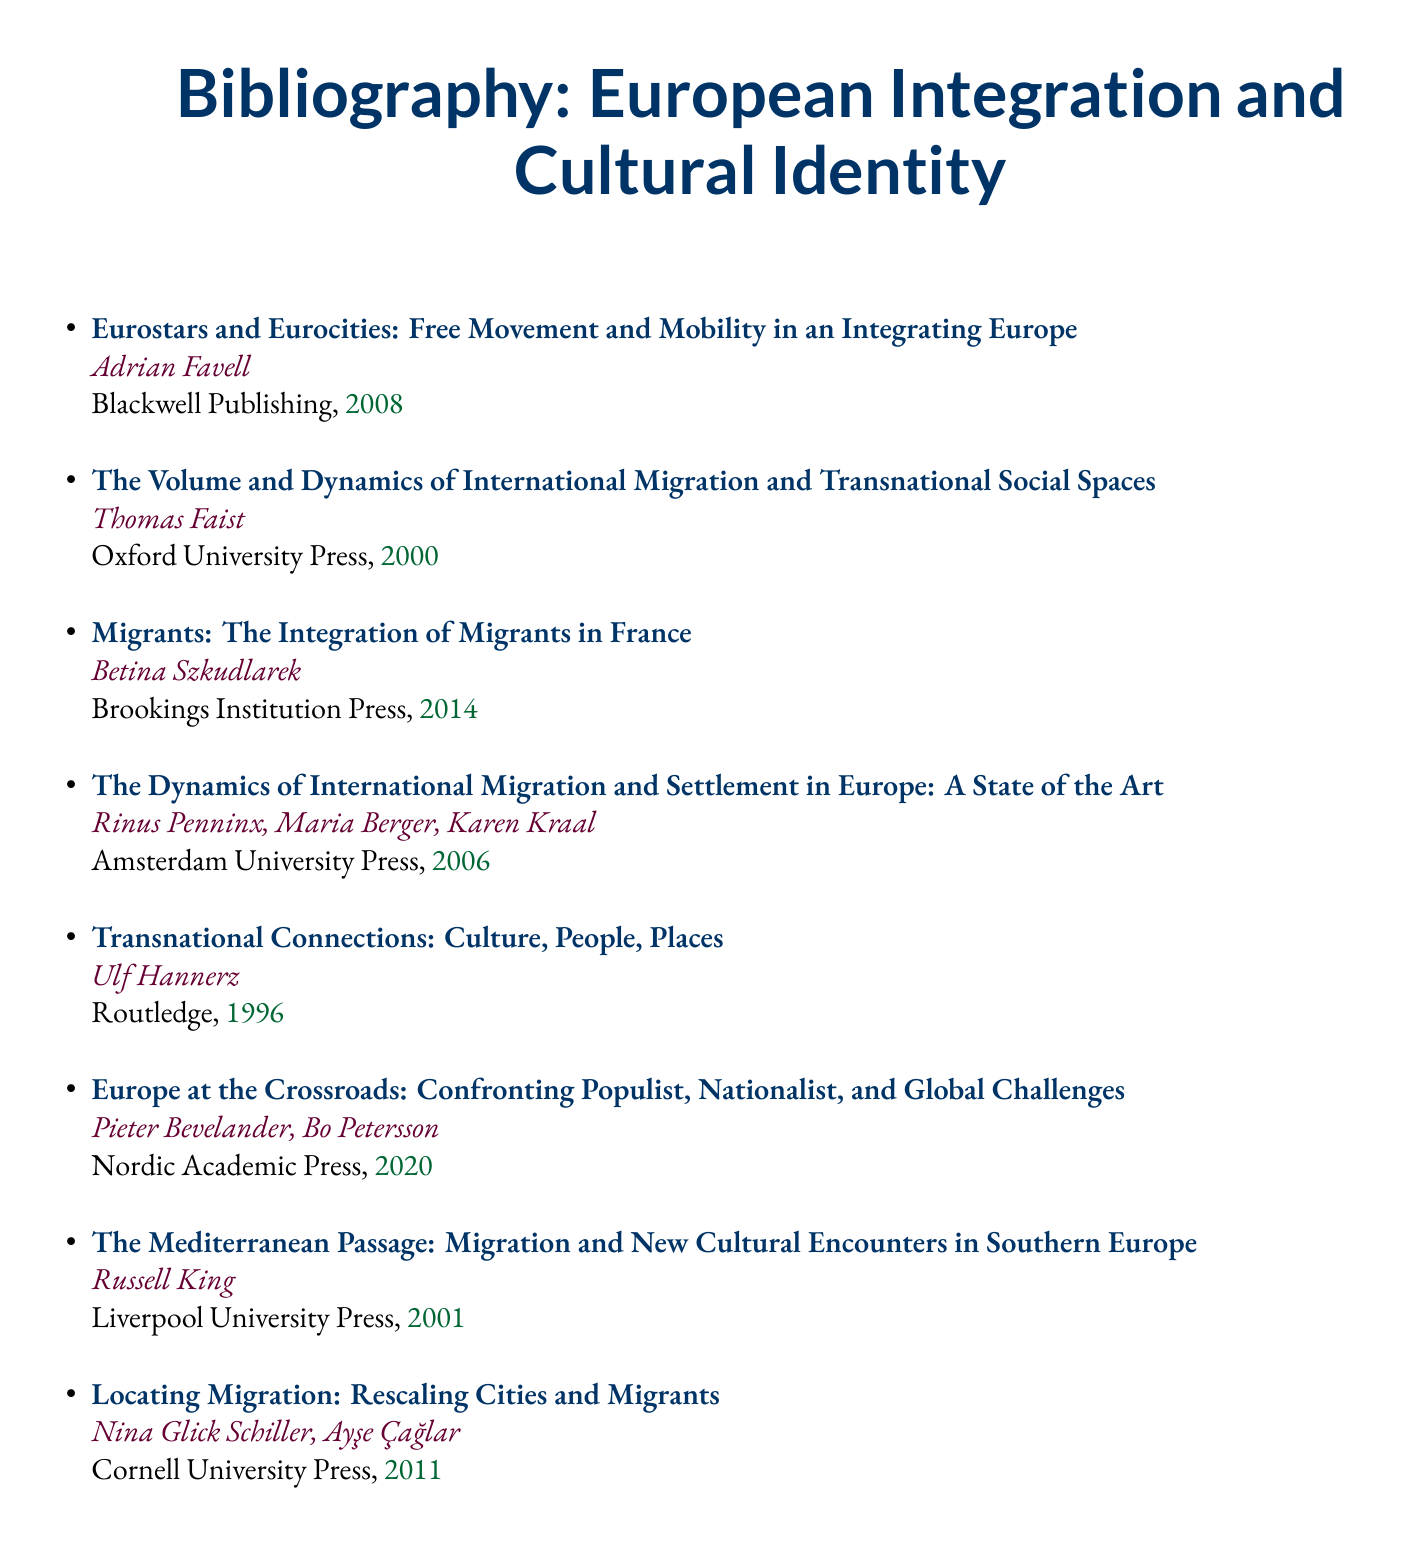What is the title of the first entry? The first entry in the bibliography is titled "Eurostars and Eurocities: Free Movement and Mobility in an Integrating Europe."
Answer: Eurostars and Eurocities: Free Movement and Mobility in an Integrating Europe Who is the author of the book published in 2014? The author of the book published in 2014 is Betina Szkudlarek.
Answer: Betina Szkudlarek What year was the text by Russell King published? The text by Russell King was published in the year 2001.
Answer: 2001 How many authors contributed to the work titled "The Dynamics of International Migration and Settlement in Europe"? There are four authors who contributed to this work: Rinus Penninx, Maria Berger, and Karen Kraal.
Answer: Four Which publisher released "Locating Migration"? "Locating Migration" was released by Cornell University Press.
Answer: Cornell University Press What is the overarching theme of the entries in this bibliography? The overarching theme of the entries relates to migration and its cultural implications within the context of European integration.
Answer: Migration and its cultural implications Is the work by Ulf Hannerz focused on transnational connections? Yes, the work by Ulf Hannerz is specifically focused on transnational connections.
Answer: Yes Which entry discusses challenges faced by Europe regarding populism and nationalism? The entry titled "Europe at the Crossroads: Confronting Populist, Nationalist, and Global Challenges" discusses these challenges.
Answer: Europe at the Crossroads: Confronting Populist, Nationalist, and Global Challenges 